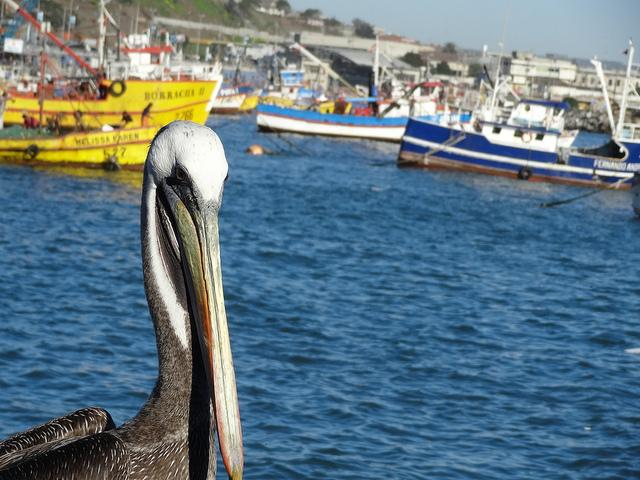On what continent was this photo most likely taken?

Choices:
A) north america
B) south america
C) europe
D) africa south america 